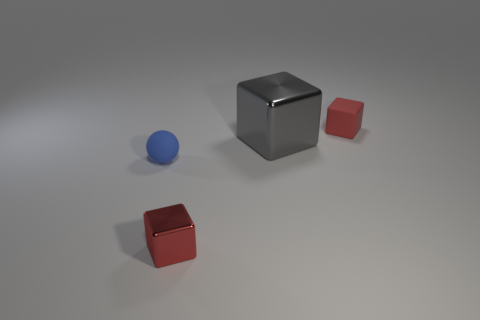Subtract all gray metal blocks. How many blocks are left? 2 Subtract all red cubes. How many cubes are left? 1 Subtract all purple spheres. How many cyan blocks are left? 0 Add 2 small blue matte cubes. How many small blue matte cubes exist? 2 Add 4 small blue rubber spheres. How many objects exist? 8 Subtract 0 yellow balls. How many objects are left? 4 Subtract all spheres. How many objects are left? 3 Subtract 1 blocks. How many blocks are left? 2 Subtract all gray spheres. Subtract all green blocks. How many spheres are left? 1 Subtract all large gray shiny blocks. Subtract all tiny blue matte blocks. How many objects are left? 3 